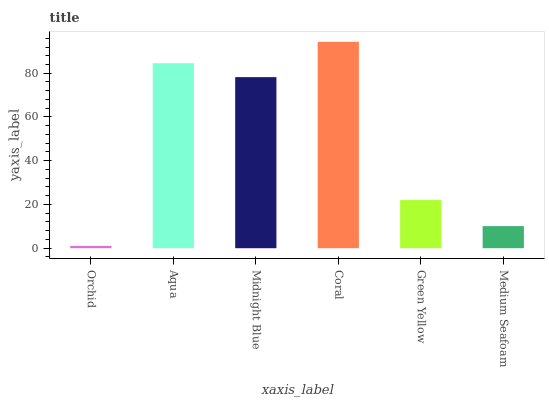Is Orchid the minimum?
Answer yes or no. Yes. Is Coral the maximum?
Answer yes or no. Yes. Is Aqua the minimum?
Answer yes or no. No. Is Aqua the maximum?
Answer yes or no. No. Is Aqua greater than Orchid?
Answer yes or no. Yes. Is Orchid less than Aqua?
Answer yes or no. Yes. Is Orchid greater than Aqua?
Answer yes or no. No. Is Aqua less than Orchid?
Answer yes or no. No. Is Midnight Blue the high median?
Answer yes or no. Yes. Is Green Yellow the low median?
Answer yes or no. Yes. Is Green Yellow the high median?
Answer yes or no. No. Is Midnight Blue the low median?
Answer yes or no. No. 